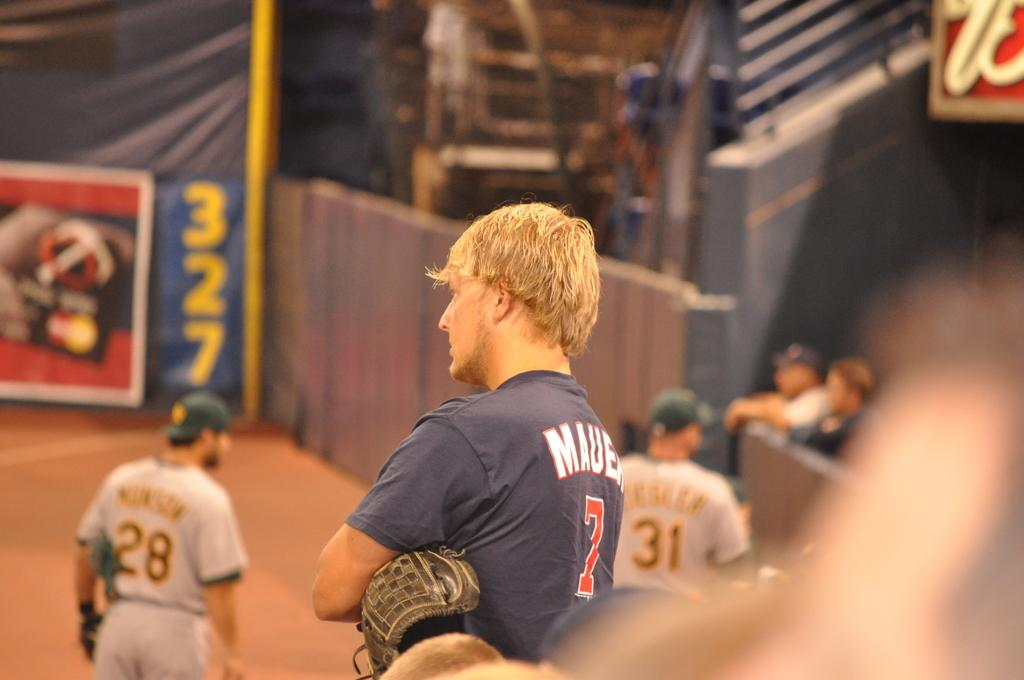<image>
Provide a brief description of the given image. Baseball players are standing on the field and one of their uniforms says Mauer 7. 